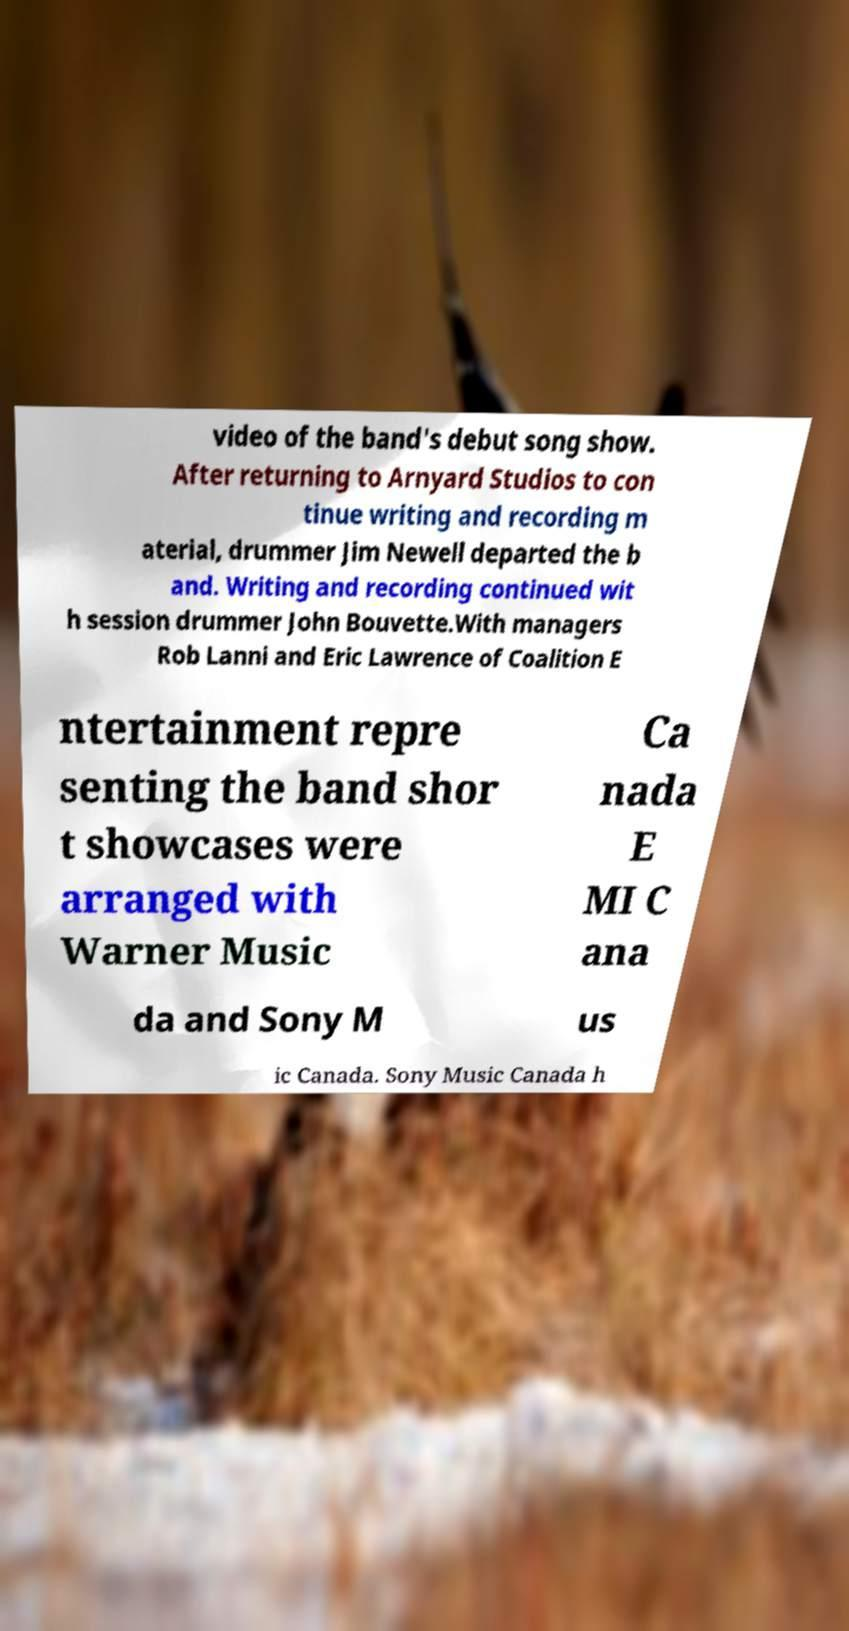Can you accurately transcribe the text from the provided image for me? video of the band's debut song show. After returning to Arnyard Studios to con tinue writing and recording m aterial, drummer Jim Newell departed the b and. Writing and recording continued wit h session drummer John Bouvette.With managers Rob Lanni and Eric Lawrence of Coalition E ntertainment repre senting the band shor t showcases were arranged with Warner Music Ca nada E MI C ana da and Sony M us ic Canada. Sony Music Canada h 